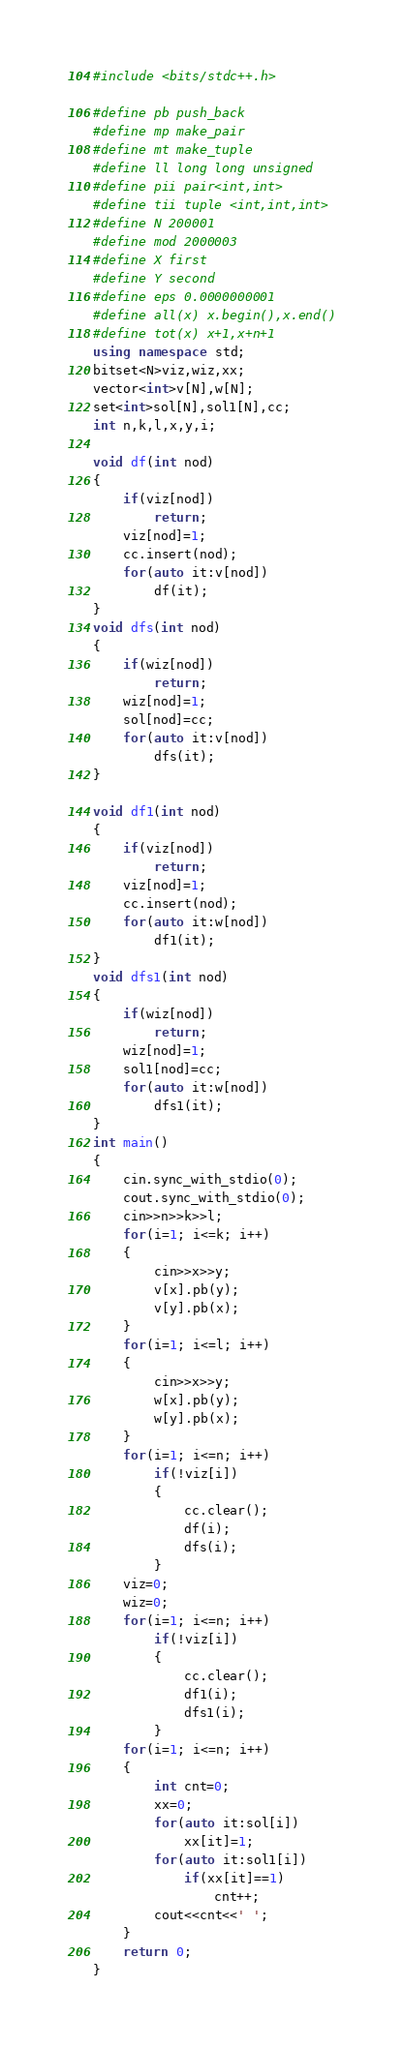Convert code to text. <code><loc_0><loc_0><loc_500><loc_500><_C++_>#include <bits/stdc++.h>

#define pb push_back
#define mp make_pair
#define mt make_tuple
#define ll long long unsigned
#define pii pair<int,int>
#define tii tuple <int,int,int>
#define N 200001
#define mod 2000003
#define X first
#define Y second
#define eps 0.0000000001
#define all(x) x.begin(),x.end()
#define tot(x) x+1,x+n+1
using namespace std;
bitset<N>viz,wiz,xx;
vector<int>v[N],w[N];
set<int>sol[N],sol1[N],cc;
int n,k,l,x,y,i;

void df(int nod)
{
    if(viz[nod])
        return;
    viz[nod]=1;
    cc.insert(nod);
    for(auto it:v[nod])
        df(it);
}
void dfs(int nod)
{
    if(wiz[nod])
        return;
    wiz[nod]=1;
    sol[nod]=cc;
    for(auto it:v[nod])
        dfs(it);
}

void df1(int nod)
{
    if(viz[nod])
        return;
    viz[nod]=1;
    cc.insert(nod);
    for(auto it:w[nod])
        df1(it);
}
void dfs1(int nod)
{
    if(wiz[nod])
        return;
    wiz[nod]=1;
    sol1[nod]=cc;
    for(auto it:w[nod])
        dfs1(it);
}
int main()
{
    cin.sync_with_stdio(0);
    cout.sync_with_stdio(0);
    cin>>n>>k>>l;
    for(i=1; i<=k; i++)
    {
        cin>>x>>y;
        v[x].pb(y);
        v[y].pb(x);
    }
    for(i=1; i<=l; i++)
    {
        cin>>x>>y;
        w[x].pb(y);
        w[y].pb(x);
    }
    for(i=1; i<=n; i++)
        if(!viz[i])
        {
            cc.clear();
            df(i);
            dfs(i);
        }
    viz=0;
    wiz=0;
    for(i=1; i<=n; i++)
        if(!viz[i])
        {
            cc.clear();
            df1(i);
            dfs1(i);
        }
    for(i=1; i<=n; i++)
    {
        int cnt=0;
        xx=0;
        for(auto it:sol[i])
            xx[it]=1;
        for(auto it:sol1[i])
            if(xx[it]==1)
                cnt++;
        cout<<cnt<<' ';
    }
    return 0;
}


</code> 